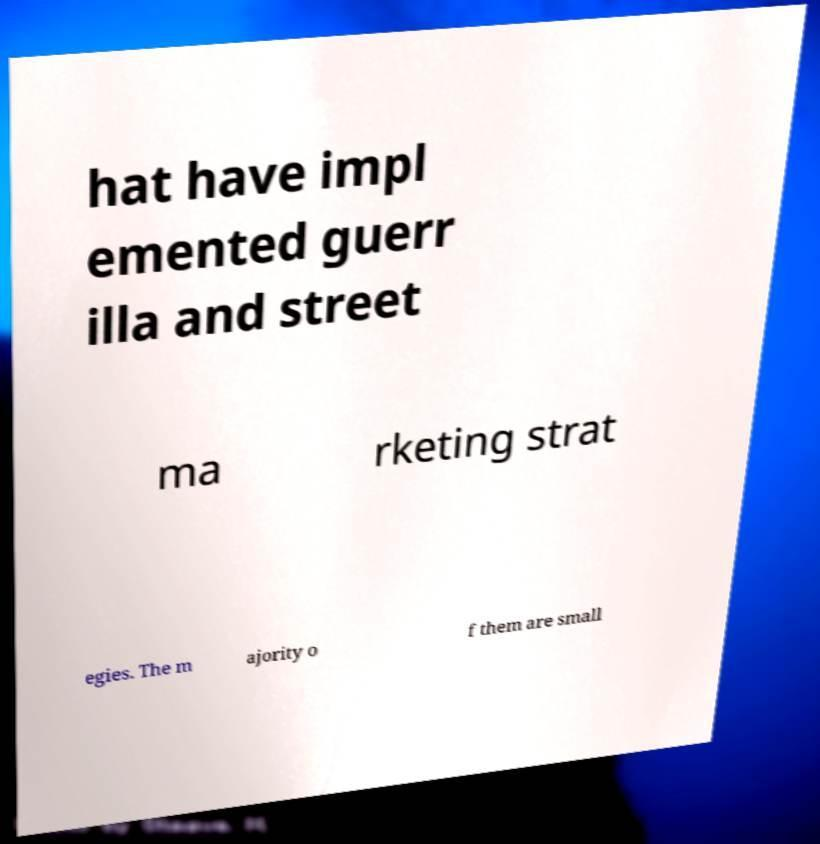Please read and relay the text visible in this image. What does it say? hat have impl emented guerr illa and street ma rketing strat egies. The m ajority o f them are small 